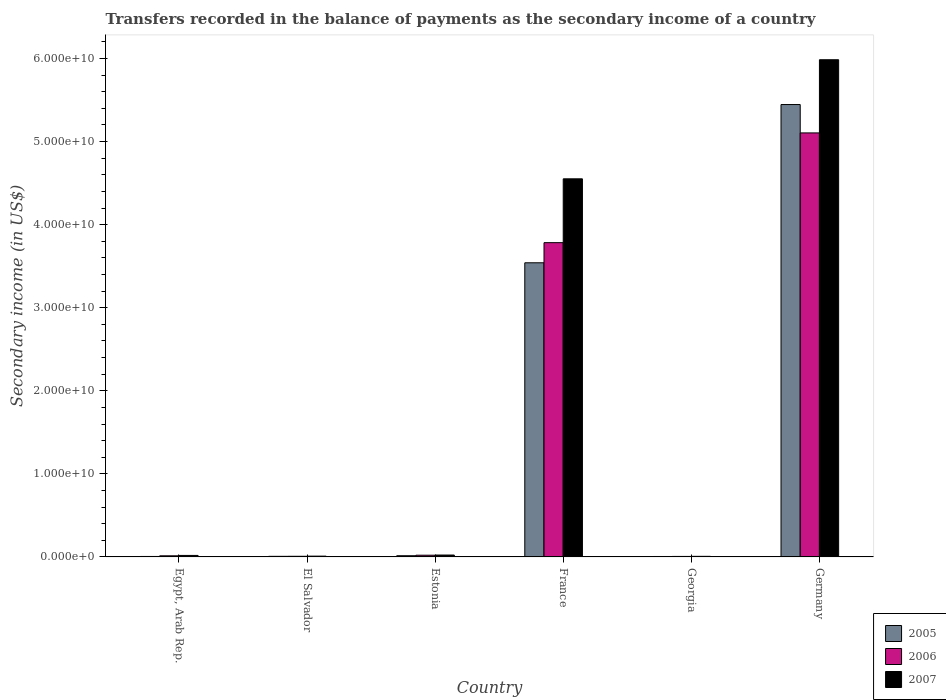How many different coloured bars are there?
Keep it short and to the point. 3. How many groups of bars are there?
Your answer should be very brief. 6. Are the number of bars on each tick of the X-axis equal?
Give a very brief answer. Yes. How many bars are there on the 6th tick from the left?
Provide a succinct answer. 3. What is the label of the 5th group of bars from the left?
Provide a succinct answer. Georgia. In how many cases, is the number of bars for a given country not equal to the number of legend labels?
Make the answer very short. 0. What is the secondary income of in 2005 in Egypt, Arab Rep.?
Ensure brevity in your answer.  5.73e+07. Across all countries, what is the maximum secondary income of in 2005?
Make the answer very short. 5.45e+1. Across all countries, what is the minimum secondary income of in 2006?
Provide a succinct answer. 5.94e+07. In which country was the secondary income of in 2007 maximum?
Your answer should be very brief. Germany. In which country was the secondary income of in 2005 minimum?
Your answer should be compact. Georgia. What is the total secondary income of in 2007 in the graph?
Give a very brief answer. 1.06e+11. What is the difference between the secondary income of in 2005 in Egypt, Arab Rep. and that in France?
Make the answer very short. -3.54e+1. What is the difference between the secondary income of in 2007 in El Salvador and the secondary income of in 2006 in Estonia?
Keep it short and to the point. -1.12e+08. What is the average secondary income of in 2005 per country?
Keep it short and to the point. 1.50e+1. What is the difference between the secondary income of of/in 2005 and secondary income of of/in 2007 in El Salvador?
Your answer should be compact. -2.43e+07. What is the ratio of the secondary income of in 2007 in Egypt, Arab Rep. to that in France?
Provide a short and direct response. 0. Is the secondary income of in 2007 in El Salvador less than that in Germany?
Give a very brief answer. Yes. What is the difference between the highest and the second highest secondary income of in 2006?
Keep it short and to the point. -5.08e+1. What is the difference between the highest and the lowest secondary income of in 2007?
Provide a short and direct response. 5.98e+1. In how many countries, is the secondary income of in 2007 greater than the average secondary income of in 2007 taken over all countries?
Offer a very short reply. 2. What does the 2nd bar from the left in El Salvador represents?
Your answer should be compact. 2006. Is it the case that in every country, the sum of the secondary income of in 2005 and secondary income of in 2007 is greater than the secondary income of in 2006?
Keep it short and to the point. Yes. What is the difference between two consecutive major ticks on the Y-axis?
Your answer should be very brief. 1.00e+1. Does the graph contain any zero values?
Provide a succinct answer. No. Does the graph contain grids?
Your response must be concise. No. How many legend labels are there?
Keep it short and to the point. 3. How are the legend labels stacked?
Your answer should be compact. Vertical. What is the title of the graph?
Provide a succinct answer. Transfers recorded in the balance of payments as the secondary income of a country. Does "1992" appear as one of the legend labels in the graph?
Ensure brevity in your answer.  No. What is the label or title of the Y-axis?
Ensure brevity in your answer.  Secondary income (in US$). What is the Secondary income (in US$) in 2005 in Egypt, Arab Rep.?
Offer a very short reply. 5.73e+07. What is the Secondary income (in US$) of 2006 in Egypt, Arab Rep.?
Make the answer very short. 1.35e+08. What is the Secondary income (in US$) of 2007 in Egypt, Arab Rep.?
Keep it short and to the point. 1.80e+08. What is the Secondary income (in US$) in 2005 in El Salvador?
Give a very brief answer. 7.14e+07. What is the Secondary income (in US$) of 2006 in El Salvador?
Give a very brief answer. 7.68e+07. What is the Secondary income (in US$) in 2007 in El Salvador?
Keep it short and to the point. 9.57e+07. What is the Secondary income (in US$) in 2005 in Estonia?
Make the answer very short. 1.46e+08. What is the Secondary income (in US$) of 2006 in Estonia?
Your answer should be very brief. 2.08e+08. What is the Secondary income (in US$) in 2007 in Estonia?
Give a very brief answer. 2.27e+08. What is the Secondary income (in US$) of 2005 in France?
Your answer should be very brief. 3.54e+1. What is the Secondary income (in US$) of 2006 in France?
Offer a very short reply. 3.78e+1. What is the Secondary income (in US$) of 2007 in France?
Offer a very short reply. 4.55e+1. What is the Secondary income (in US$) of 2005 in Georgia?
Your response must be concise. 5.19e+07. What is the Secondary income (in US$) of 2006 in Georgia?
Make the answer very short. 5.94e+07. What is the Secondary income (in US$) in 2007 in Georgia?
Keep it short and to the point. 7.21e+07. What is the Secondary income (in US$) in 2005 in Germany?
Offer a terse response. 5.45e+1. What is the Secondary income (in US$) of 2006 in Germany?
Your answer should be compact. 5.10e+1. What is the Secondary income (in US$) of 2007 in Germany?
Offer a very short reply. 5.99e+1. Across all countries, what is the maximum Secondary income (in US$) of 2005?
Your answer should be compact. 5.45e+1. Across all countries, what is the maximum Secondary income (in US$) of 2006?
Offer a terse response. 5.10e+1. Across all countries, what is the maximum Secondary income (in US$) of 2007?
Keep it short and to the point. 5.99e+1. Across all countries, what is the minimum Secondary income (in US$) of 2005?
Keep it short and to the point. 5.19e+07. Across all countries, what is the minimum Secondary income (in US$) of 2006?
Your answer should be very brief. 5.94e+07. Across all countries, what is the minimum Secondary income (in US$) of 2007?
Your answer should be very brief. 7.21e+07. What is the total Secondary income (in US$) in 2005 in the graph?
Offer a terse response. 9.02e+1. What is the total Secondary income (in US$) of 2006 in the graph?
Keep it short and to the point. 8.94e+1. What is the total Secondary income (in US$) of 2007 in the graph?
Keep it short and to the point. 1.06e+11. What is the difference between the Secondary income (in US$) in 2005 in Egypt, Arab Rep. and that in El Salvador?
Give a very brief answer. -1.41e+07. What is the difference between the Secondary income (in US$) of 2006 in Egypt, Arab Rep. and that in El Salvador?
Offer a terse response. 5.83e+07. What is the difference between the Secondary income (in US$) in 2007 in Egypt, Arab Rep. and that in El Salvador?
Make the answer very short. 8.42e+07. What is the difference between the Secondary income (in US$) of 2005 in Egypt, Arab Rep. and that in Estonia?
Your answer should be compact. -8.83e+07. What is the difference between the Secondary income (in US$) in 2006 in Egypt, Arab Rep. and that in Estonia?
Make the answer very short. -7.26e+07. What is the difference between the Secondary income (in US$) of 2007 in Egypt, Arab Rep. and that in Estonia?
Provide a succinct answer. -4.70e+07. What is the difference between the Secondary income (in US$) in 2005 in Egypt, Arab Rep. and that in France?
Make the answer very short. -3.54e+1. What is the difference between the Secondary income (in US$) of 2006 in Egypt, Arab Rep. and that in France?
Your answer should be compact. -3.77e+1. What is the difference between the Secondary income (in US$) in 2007 in Egypt, Arab Rep. and that in France?
Your answer should be very brief. -4.53e+1. What is the difference between the Secondary income (in US$) in 2005 in Egypt, Arab Rep. and that in Georgia?
Your response must be concise. 5.35e+06. What is the difference between the Secondary income (in US$) of 2006 in Egypt, Arab Rep. and that in Georgia?
Offer a very short reply. 7.57e+07. What is the difference between the Secondary income (in US$) in 2007 in Egypt, Arab Rep. and that in Georgia?
Offer a very short reply. 1.08e+08. What is the difference between the Secondary income (in US$) of 2005 in Egypt, Arab Rep. and that in Germany?
Your answer should be compact. -5.44e+1. What is the difference between the Secondary income (in US$) of 2006 in Egypt, Arab Rep. and that in Germany?
Your answer should be very brief. -5.09e+1. What is the difference between the Secondary income (in US$) in 2007 in Egypt, Arab Rep. and that in Germany?
Your answer should be compact. -5.97e+1. What is the difference between the Secondary income (in US$) in 2005 in El Salvador and that in Estonia?
Give a very brief answer. -7.42e+07. What is the difference between the Secondary income (in US$) in 2006 in El Salvador and that in Estonia?
Your response must be concise. -1.31e+08. What is the difference between the Secondary income (in US$) in 2007 in El Salvador and that in Estonia?
Ensure brevity in your answer.  -1.31e+08. What is the difference between the Secondary income (in US$) of 2005 in El Salvador and that in France?
Provide a short and direct response. -3.53e+1. What is the difference between the Secondary income (in US$) in 2006 in El Salvador and that in France?
Your answer should be very brief. -3.78e+1. What is the difference between the Secondary income (in US$) in 2007 in El Salvador and that in France?
Your answer should be compact. -4.54e+1. What is the difference between the Secondary income (in US$) in 2005 in El Salvador and that in Georgia?
Your response must be concise. 1.95e+07. What is the difference between the Secondary income (in US$) of 2006 in El Salvador and that in Georgia?
Your response must be concise. 1.74e+07. What is the difference between the Secondary income (in US$) of 2007 in El Salvador and that in Georgia?
Your answer should be compact. 2.37e+07. What is the difference between the Secondary income (in US$) of 2005 in El Salvador and that in Germany?
Your answer should be compact. -5.44e+1. What is the difference between the Secondary income (in US$) of 2006 in El Salvador and that in Germany?
Your response must be concise. -5.10e+1. What is the difference between the Secondary income (in US$) in 2007 in El Salvador and that in Germany?
Your answer should be compact. -5.98e+1. What is the difference between the Secondary income (in US$) in 2005 in Estonia and that in France?
Keep it short and to the point. -3.53e+1. What is the difference between the Secondary income (in US$) of 2006 in Estonia and that in France?
Provide a succinct answer. -3.76e+1. What is the difference between the Secondary income (in US$) in 2007 in Estonia and that in France?
Make the answer very short. -4.53e+1. What is the difference between the Secondary income (in US$) in 2005 in Estonia and that in Georgia?
Make the answer very short. 9.36e+07. What is the difference between the Secondary income (in US$) of 2006 in Estonia and that in Georgia?
Your response must be concise. 1.48e+08. What is the difference between the Secondary income (in US$) of 2007 in Estonia and that in Georgia?
Make the answer very short. 1.55e+08. What is the difference between the Secondary income (in US$) of 2005 in Estonia and that in Germany?
Provide a succinct answer. -5.43e+1. What is the difference between the Secondary income (in US$) in 2006 in Estonia and that in Germany?
Your answer should be compact. -5.08e+1. What is the difference between the Secondary income (in US$) of 2007 in Estonia and that in Germany?
Keep it short and to the point. -5.96e+1. What is the difference between the Secondary income (in US$) of 2005 in France and that in Georgia?
Your response must be concise. 3.54e+1. What is the difference between the Secondary income (in US$) of 2006 in France and that in Georgia?
Provide a succinct answer. 3.78e+1. What is the difference between the Secondary income (in US$) of 2007 in France and that in Georgia?
Make the answer very short. 4.54e+1. What is the difference between the Secondary income (in US$) in 2005 in France and that in Germany?
Ensure brevity in your answer.  -1.91e+1. What is the difference between the Secondary income (in US$) in 2006 in France and that in Germany?
Your answer should be very brief. -1.32e+1. What is the difference between the Secondary income (in US$) in 2007 in France and that in Germany?
Ensure brevity in your answer.  -1.43e+1. What is the difference between the Secondary income (in US$) in 2005 in Georgia and that in Germany?
Give a very brief answer. -5.44e+1. What is the difference between the Secondary income (in US$) of 2006 in Georgia and that in Germany?
Provide a short and direct response. -5.10e+1. What is the difference between the Secondary income (in US$) of 2007 in Georgia and that in Germany?
Give a very brief answer. -5.98e+1. What is the difference between the Secondary income (in US$) of 2005 in Egypt, Arab Rep. and the Secondary income (in US$) of 2006 in El Salvador?
Provide a succinct answer. -1.95e+07. What is the difference between the Secondary income (in US$) of 2005 in Egypt, Arab Rep. and the Secondary income (in US$) of 2007 in El Salvador?
Provide a short and direct response. -3.84e+07. What is the difference between the Secondary income (in US$) in 2006 in Egypt, Arab Rep. and the Secondary income (in US$) in 2007 in El Salvador?
Your answer should be very brief. 3.94e+07. What is the difference between the Secondary income (in US$) in 2005 in Egypt, Arab Rep. and the Secondary income (in US$) in 2006 in Estonia?
Offer a terse response. -1.50e+08. What is the difference between the Secondary income (in US$) of 2005 in Egypt, Arab Rep. and the Secondary income (in US$) of 2007 in Estonia?
Your answer should be very brief. -1.70e+08. What is the difference between the Secondary income (in US$) of 2006 in Egypt, Arab Rep. and the Secondary income (in US$) of 2007 in Estonia?
Ensure brevity in your answer.  -9.18e+07. What is the difference between the Secondary income (in US$) of 2005 in Egypt, Arab Rep. and the Secondary income (in US$) of 2006 in France?
Ensure brevity in your answer.  -3.78e+1. What is the difference between the Secondary income (in US$) in 2005 in Egypt, Arab Rep. and the Secondary income (in US$) in 2007 in France?
Keep it short and to the point. -4.55e+1. What is the difference between the Secondary income (in US$) of 2006 in Egypt, Arab Rep. and the Secondary income (in US$) of 2007 in France?
Provide a succinct answer. -4.54e+1. What is the difference between the Secondary income (in US$) of 2005 in Egypt, Arab Rep. and the Secondary income (in US$) of 2006 in Georgia?
Make the answer very short. -2.07e+06. What is the difference between the Secondary income (in US$) of 2005 in Egypt, Arab Rep. and the Secondary income (in US$) of 2007 in Georgia?
Provide a short and direct response. -1.48e+07. What is the difference between the Secondary income (in US$) of 2006 in Egypt, Arab Rep. and the Secondary income (in US$) of 2007 in Georgia?
Your answer should be compact. 6.30e+07. What is the difference between the Secondary income (in US$) in 2005 in Egypt, Arab Rep. and the Secondary income (in US$) in 2006 in Germany?
Provide a short and direct response. -5.10e+1. What is the difference between the Secondary income (in US$) in 2005 in Egypt, Arab Rep. and the Secondary income (in US$) in 2007 in Germany?
Make the answer very short. -5.98e+1. What is the difference between the Secondary income (in US$) of 2006 in Egypt, Arab Rep. and the Secondary income (in US$) of 2007 in Germany?
Provide a short and direct response. -5.97e+1. What is the difference between the Secondary income (in US$) of 2005 in El Salvador and the Secondary income (in US$) of 2006 in Estonia?
Make the answer very short. -1.36e+08. What is the difference between the Secondary income (in US$) of 2005 in El Salvador and the Secondary income (in US$) of 2007 in Estonia?
Your response must be concise. -1.55e+08. What is the difference between the Secondary income (in US$) of 2006 in El Salvador and the Secondary income (in US$) of 2007 in Estonia?
Make the answer very short. -1.50e+08. What is the difference between the Secondary income (in US$) of 2005 in El Salvador and the Secondary income (in US$) of 2006 in France?
Your answer should be very brief. -3.78e+1. What is the difference between the Secondary income (in US$) of 2005 in El Salvador and the Secondary income (in US$) of 2007 in France?
Offer a terse response. -4.54e+1. What is the difference between the Secondary income (in US$) of 2006 in El Salvador and the Secondary income (in US$) of 2007 in France?
Keep it short and to the point. -4.54e+1. What is the difference between the Secondary income (in US$) in 2005 in El Salvador and the Secondary income (in US$) in 2006 in Georgia?
Provide a succinct answer. 1.20e+07. What is the difference between the Secondary income (in US$) of 2005 in El Salvador and the Secondary income (in US$) of 2007 in Georgia?
Offer a very short reply. -6.62e+05. What is the difference between the Secondary income (in US$) in 2006 in El Salvador and the Secondary income (in US$) in 2007 in Georgia?
Provide a succinct answer. 4.72e+06. What is the difference between the Secondary income (in US$) of 2005 in El Salvador and the Secondary income (in US$) of 2006 in Germany?
Your answer should be very brief. -5.10e+1. What is the difference between the Secondary income (in US$) in 2005 in El Salvador and the Secondary income (in US$) in 2007 in Germany?
Offer a very short reply. -5.98e+1. What is the difference between the Secondary income (in US$) in 2006 in El Salvador and the Secondary income (in US$) in 2007 in Germany?
Your answer should be very brief. -5.98e+1. What is the difference between the Secondary income (in US$) in 2005 in Estonia and the Secondary income (in US$) in 2006 in France?
Make the answer very short. -3.77e+1. What is the difference between the Secondary income (in US$) in 2005 in Estonia and the Secondary income (in US$) in 2007 in France?
Offer a terse response. -4.54e+1. What is the difference between the Secondary income (in US$) of 2006 in Estonia and the Secondary income (in US$) of 2007 in France?
Give a very brief answer. -4.53e+1. What is the difference between the Secondary income (in US$) of 2005 in Estonia and the Secondary income (in US$) of 2006 in Georgia?
Give a very brief answer. 8.62e+07. What is the difference between the Secondary income (in US$) of 2005 in Estonia and the Secondary income (in US$) of 2007 in Georgia?
Provide a succinct answer. 7.35e+07. What is the difference between the Secondary income (in US$) in 2006 in Estonia and the Secondary income (in US$) in 2007 in Georgia?
Provide a succinct answer. 1.36e+08. What is the difference between the Secondary income (in US$) of 2005 in Estonia and the Secondary income (in US$) of 2006 in Germany?
Ensure brevity in your answer.  -5.09e+1. What is the difference between the Secondary income (in US$) of 2005 in Estonia and the Secondary income (in US$) of 2007 in Germany?
Your response must be concise. -5.97e+1. What is the difference between the Secondary income (in US$) in 2006 in Estonia and the Secondary income (in US$) in 2007 in Germany?
Your answer should be very brief. -5.96e+1. What is the difference between the Secondary income (in US$) in 2005 in France and the Secondary income (in US$) in 2006 in Georgia?
Offer a terse response. 3.54e+1. What is the difference between the Secondary income (in US$) of 2005 in France and the Secondary income (in US$) of 2007 in Georgia?
Offer a terse response. 3.53e+1. What is the difference between the Secondary income (in US$) of 2006 in France and the Secondary income (in US$) of 2007 in Georgia?
Your answer should be very brief. 3.78e+1. What is the difference between the Secondary income (in US$) of 2005 in France and the Secondary income (in US$) of 2006 in Germany?
Keep it short and to the point. -1.56e+1. What is the difference between the Secondary income (in US$) of 2005 in France and the Secondary income (in US$) of 2007 in Germany?
Offer a very short reply. -2.44e+1. What is the difference between the Secondary income (in US$) of 2006 in France and the Secondary income (in US$) of 2007 in Germany?
Provide a short and direct response. -2.20e+1. What is the difference between the Secondary income (in US$) in 2005 in Georgia and the Secondary income (in US$) in 2006 in Germany?
Ensure brevity in your answer.  -5.10e+1. What is the difference between the Secondary income (in US$) in 2005 in Georgia and the Secondary income (in US$) in 2007 in Germany?
Provide a short and direct response. -5.98e+1. What is the difference between the Secondary income (in US$) of 2006 in Georgia and the Secondary income (in US$) of 2007 in Germany?
Make the answer very short. -5.98e+1. What is the average Secondary income (in US$) in 2005 per country?
Keep it short and to the point. 1.50e+1. What is the average Secondary income (in US$) in 2006 per country?
Ensure brevity in your answer.  1.49e+1. What is the average Secondary income (in US$) of 2007 per country?
Your answer should be compact. 1.77e+1. What is the difference between the Secondary income (in US$) of 2005 and Secondary income (in US$) of 2006 in Egypt, Arab Rep.?
Offer a very short reply. -7.78e+07. What is the difference between the Secondary income (in US$) in 2005 and Secondary income (in US$) in 2007 in Egypt, Arab Rep.?
Offer a very short reply. -1.23e+08. What is the difference between the Secondary income (in US$) in 2006 and Secondary income (in US$) in 2007 in Egypt, Arab Rep.?
Offer a very short reply. -4.48e+07. What is the difference between the Secondary income (in US$) of 2005 and Secondary income (in US$) of 2006 in El Salvador?
Your response must be concise. -5.38e+06. What is the difference between the Secondary income (in US$) in 2005 and Secondary income (in US$) in 2007 in El Salvador?
Your answer should be very brief. -2.43e+07. What is the difference between the Secondary income (in US$) of 2006 and Secondary income (in US$) of 2007 in El Salvador?
Give a very brief answer. -1.90e+07. What is the difference between the Secondary income (in US$) of 2005 and Secondary income (in US$) of 2006 in Estonia?
Make the answer very short. -6.21e+07. What is the difference between the Secondary income (in US$) of 2005 and Secondary income (in US$) of 2007 in Estonia?
Give a very brief answer. -8.13e+07. What is the difference between the Secondary income (in US$) in 2006 and Secondary income (in US$) in 2007 in Estonia?
Provide a succinct answer. -1.92e+07. What is the difference between the Secondary income (in US$) of 2005 and Secondary income (in US$) of 2006 in France?
Provide a short and direct response. -2.42e+09. What is the difference between the Secondary income (in US$) of 2005 and Secondary income (in US$) of 2007 in France?
Ensure brevity in your answer.  -1.01e+1. What is the difference between the Secondary income (in US$) of 2006 and Secondary income (in US$) of 2007 in France?
Make the answer very short. -7.69e+09. What is the difference between the Secondary income (in US$) of 2005 and Secondary income (in US$) of 2006 in Georgia?
Your response must be concise. -7.43e+06. What is the difference between the Secondary income (in US$) of 2005 and Secondary income (in US$) of 2007 in Georgia?
Provide a short and direct response. -2.01e+07. What is the difference between the Secondary income (in US$) of 2006 and Secondary income (in US$) of 2007 in Georgia?
Ensure brevity in your answer.  -1.27e+07. What is the difference between the Secondary income (in US$) of 2005 and Secondary income (in US$) of 2006 in Germany?
Offer a terse response. 3.42e+09. What is the difference between the Secondary income (in US$) of 2005 and Secondary income (in US$) of 2007 in Germany?
Provide a succinct answer. -5.39e+09. What is the difference between the Secondary income (in US$) of 2006 and Secondary income (in US$) of 2007 in Germany?
Give a very brief answer. -8.81e+09. What is the ratio of the Secondary income (in US$) of 2005 in Egypt, Arab Rep. to that in El Salvador?
Provide a short and direct response. 0.8. What is the ratio of the Secondary income (in US$) of 2006 in Egypt, Arab Rep. to that in El Salvador?
Your answer should be very brief. 1.76. What is the ratio of the Secondary income (in US$) of 2007 in Egypt, Arab Rep. to that in El Salvador?
Offer a terse response. 1.88. What is the ratio of the Secondary income (in US$) in 2005 in Egypt, Arab Rep. to that in Estonia?
Provide a succinct answer. 0.39. What is the ratio of the Secondary income (in US$) in 2006 in Egypt, Arab Rep. to that in Estonia?
Offer a terse response. 0.65. What is the ratio of the Secondary income (in US$) in 2007 in Egypt, Arab Rep. to that in Estonia?
Your response must be concise. 0.79. What is the ratio of the Secondary income (in US$) in 2005 in Egypt, Arab Rep. to that in France?
Offer a very short reply. 0. What is the ratio of the Secondary income (in US$) of 2006 in Egypt, Arab Rep. to that in France?
Offer a terse response. 0. What is the ratio of the Secondary income (in US$) in 2007 in Egypt, Arab Rep. to that in France?
Offer a terse response. 0. What is the ratio of the Secondary income (in US$) in 2005 in Egypt, Arab Rep. to that in Georgia?
Your answer should be compact. 1.1. What is the ratio of the Secondary income (in US$) of 2006 in Egypt, Arab Rep. to that in Georgia?
Give a very brief answer. 2.28. What is the ratio of the Secondary income (in US$) in 2007 in Egypt, Arab Rep. to that in Georgia?
Keep it short and to the point. 2.5. What is the ratio of the Secondary income (in US$) in 2005 in Egypt, Arab Rep. to that in Germany?
Offer a terse response. 0. What is the ratio of the Secondary income (in US$) of 2006 in Egypt, Arab Rep. to that in Germany?
Make the answer very short. 0. What is the ratio of the Secondary income (in US$) of 2007 in Egypt, Arab Rep. to that in Germany?
Provide a succinct answer. 0. What is the ratio of the Secondary income (in US$) of 2005 in El Salvador to that in Estonia?
Your answer should be compact. 0.49. What is the ratio of the Secondary income (in US$) in 2006 in El Salvador to that in Estonia?
Provide a succinct answer. 0.37. What is the ratio of the Secondary income (in US$) of 2007 in El Salvador to that in Estonia?
Provide a succinct answer. 0.42. What is the ratio of the Secondary income (in US$) of 2005 in El Salvador to that in France?
Provide a short and direct response. 0. What is the ratio of the Secondary income (in US$) in 2006 in El Salvador to that in France?
Your answer should be compact. 0. What is the ratio of the Secondary income (in US$) in 2007 in El Salvador to that in France?
Provide a short and direct response. 0. What is the ratio of the Secondary income (in US$) in 2005 in El Salvador to that in Georgia?
Offer a terse response. 1.37. What is the ratio of the Secondary income (in US$) of 2006 in El Salvador to that in Georgia?
Provide a short and direct response. 1.29. What is the ratio of the Secondary income (in US$) in 2007 in El Salvador to that in Georgia?
Offer a very short reply. 1.33. What is the ratio of the Secondary income (in US$) of 2005 in El Salvador to that in Germany?
Make the answer very short. 0. What is the ratio of the Secondary income (in US$) of 2006 in El Salvador to that in Germany?
Your answer should be very brief. 0. What is the ratio of the Secondary income (in US$) in 2007 in El Salvador to that in Germany?
Your response must be concise. 0. What is the ratio of the Secondary income (in US$) in 2005 in Estonia to that in France?
Give a very brief answer. 0. What is the ratio of the Secondary income (in US$) in 2006 in Estonia to that in France?
Your answer should be very brief. 0.01. What is the ratio of the Secondary income (in US$) in 2007 in Estonia to that in France?
Offer a terse response. 0.01. What is the ratio of the Secondary income (in US$) of 2005 in Estonia to that in Georgia?
Ensure brevity in your answer.  2.8. What is the ratio of the Secondary income (in US$) in 2006 in Estonia to that in Georgia?
Your answer should be compact. 3.5. What is the ratio of the Secondary income (in US$) in 2007 in Estonia to that in Georgia?
Offer a very short reply. 3.15. What is the ratio of the Secondary income (in US$) of 2005 in Estonia to that in Germany?
Offer a very short reply. 0. What is the ratio of the Secondary income (in US$) of 2006 in Estonia to that in Germany?
Keep it short and to the point. 0. What is the ratio of the Secondary income (in US$) of 2007 in Estonia to that in Germany?
Your response must be concise. 0. What is the ratio of the Secondary income (in US$) in 2005 in France to that in Georgia?
Give a very brief answer. 681.68. What is the ratio of the Secondary income (in US$) in 2006 in France to that in Georgia?
Offer a terse response. 637.24. What is the ratio of the Secondary income (in US$) in 2007 in France to that in Georgia?
Give a very brief answer. 631.67. What is the ratio of the Secondary income (in US$) in 2005 in France to that in Germany?
Offer a very short reply. 0.65. What is the ratio of the Secondary income (in US$) of 2006 in France to that in Germany?
Make the answer very short. 0.74. What is the ratio of the Secondary income (in US$) in 2007 in France to that in Germany?
Your answer should be very brief. 0.76. What is the ratio of the Secondary income (in US$) in 2005 in Georgia to that in Germany?
Provide a short and direct response. 0. What is the ratio of the Secondary income (in US$) in 2006 in Georgia to that in Germany?
Make the answer very short. 0. What is the ratio of the Secondary income (in US$) of 2007 in Georgia to that in Germany?
Your answer should be compact. 0. What is the difference between the highest and the second highest Secondary income (in US$) in 2005?
Your response must be concise. 1.91e+1. What is the difference between the highest and the second highest Secondary income (in US$) of 2006?
Offer a terse response. 1.32e+1. What is the difference between the highest and the second highest Secondary income (in US$) of 2007?
Give a very brief answer. 1.43e+1. What is the difference between the highest and the lowest Secondary income (in US$) in 2005?
Give a very brief answer. 5.44e+1. What is the difference between the highest and the lowest Secondary income (in US$) of 2006?
Your answer should be very brief. 5.10e+1. What is the difference between the highest and the lowest Secondary income (in US$) in 2007?
Provide a short and direct response. 5.98e+1. 